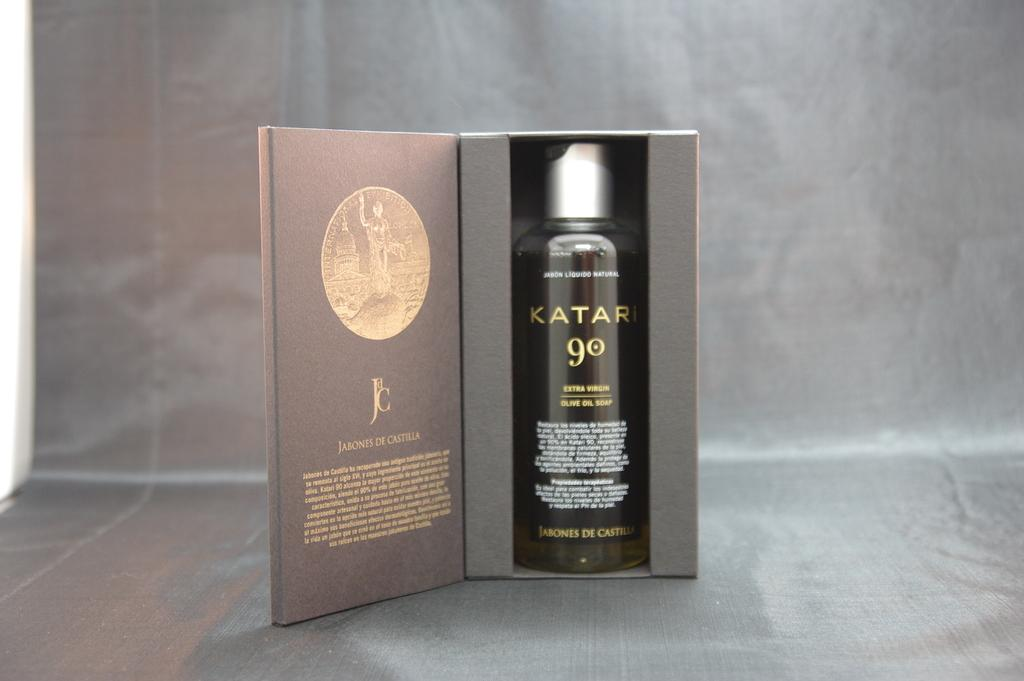Provide a one-sentence caption for the provided image. a Katar 90 bottle still in the box. 